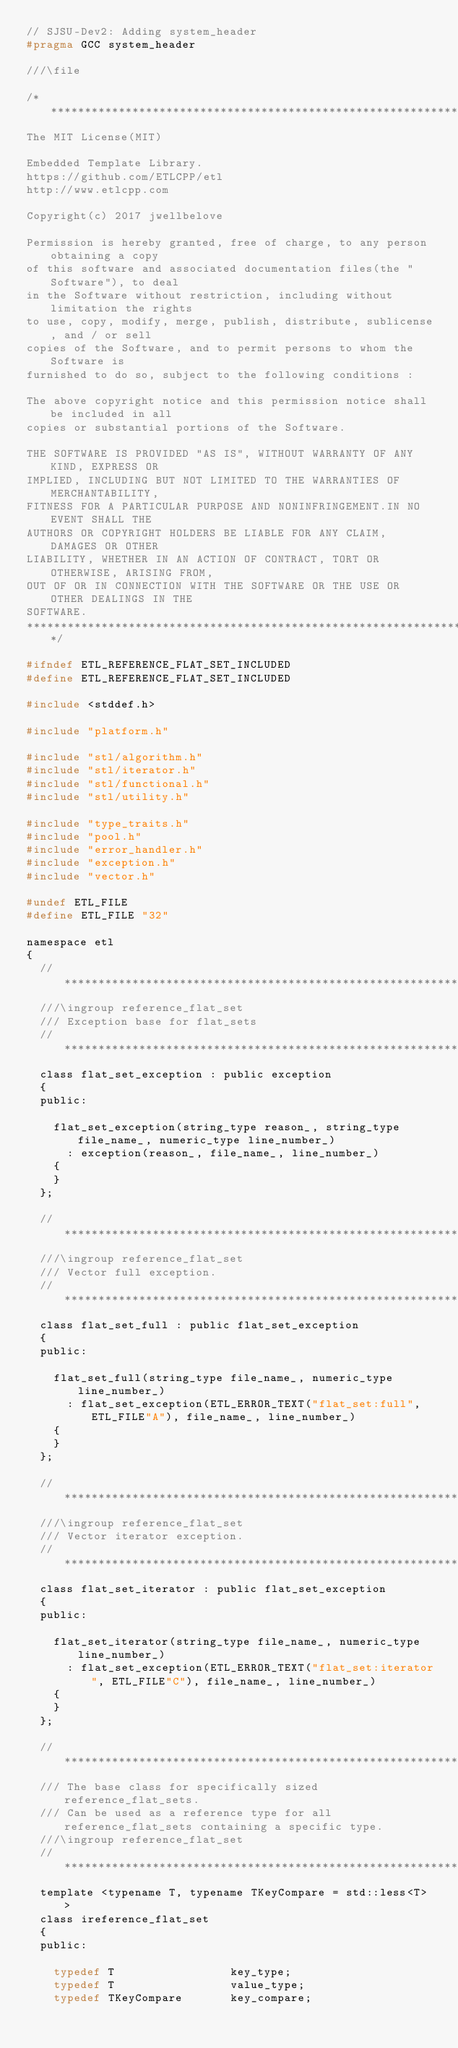<code> <loc_0><loc_0><loc_500><loc_500><_C_>// SJSU-Dev2: Adding system_header
#pragma GCC system_header

///\file

/******************************************************************************
The MIT License(MIT)

Embedded Template Library.
https://github.com/ETLCPP/etl
http://www.etlcpp.com

Copyright(c) 2017 jwellbelove

Permission is hereby granted, free of charge, to any person obtaining a copy
of this software and associated documentation files(the "Software"), to deal
in the Software without restriction, including without limitation the rights
to use, copy, modify, merge, publish, distribute, sublicense, and / or sell
copies of the Software, and to permit persons to whom the Software is
furnished to do so, subject to the following conditions :

The above copyright notice and this permission notice shall be included in all
copies or substantial portions of the Software.

THE SOFTWARE IS PROVIDED "AS IS", WITHOUT WARRANTY OF ANY KIND, EXPRESS OR
IMPLIED, INCLUDING BUT NOT LIMITED TO THE WARRANTIES OF MERCHANTABILITY,
FITNESS FOR A PARTICULAR PURPOSE AND NONINFRINGEMENT.IN NO EVENT SHALL THE
AUTHORS OR COPYRIGHT HOLDERS BE LIABLE FOR ANY CLAIM, DAMAGES OR OTHER
LIABILITY, WHETHER IN AN ACTION OF CONTRACT, TORT OR OTHERWISE, ARISING FROM,
OUT OF OR IN CONNECTION WITH THE SOFTWARE OR THE USE OR OTHER DEALINGS IN THE
SOFTWARE.
******************************************************************************/

#ifndef ETL_REFERENCE_FLAT_SET_INCLUDED
#define ETL_REFERENCE_FLAT_SET_INCLUDED

#include <stddef.h>

#include "platform.h"

#include "stl/algorithm.h"
#include "stl/iterator.h"
#include "stl/functional.h"
#include "stl/utility.h"

#include "type_traits.h"
#include "pool.h"
#include "error_handler.h"
#include "exception.h"
#include "vector.h"

#undef ETL_FILE
#define ETL_FILE "32"

namespace etl
{
  //***************************************************************************
  ///\ingroup reference_flat_set
  /// Exception base for flat_sets
  //***************************************************************************
  class flat_set_exception : public exception
  {
  public:

    flat_set_exception(string_type reason_, string_type file_name_, numeric_type line_number_)
      : exception(reason_, file_name_, line_number_)
    {
    }
  };

  //***************************************************************************
  ///\ingroup reference_flat_set
  /// Vector full exception.
  //***************************************************************************
  class flat_set_full : public flat_set_exception
  {
  public:

    flat_set_full(string_type file_name_, numeric_type line_number_)
      : flat_set_exception(ETL_ERROR_TEXT("flat_set:full", ETL_FILE"A"), file_name_, line_number_)
    {
    }
  };

  //***************************************************************************
  ///\ingroup reference_flat_set
  /// Vector iterator exception.
  //***************************************************************************
  class flat_set_iterator : public flat_set_exception
  {
  public:

    flat_set_iterator(string_type file_name_, numeric_type line_number_)
      : flat_set_exception(ETL_ERROR_TEXT("flat_set:iterator", ETL_FILE"C"), file_name_, line_number_)
    {
    }
  };

  //***************************************************************************
  /// The base class for specifically sized reference_flat_sets.
  /// Can be used as a reference type for all reference_flat_sets containing a specific type.
  ///\ingroup reference_flat_set
  //***************************************************************************
  template <typename T, typename TKeyCompare = std::less<T> >
  class ireference_flat_set
  {
  public:

    typedef T                 key_type;
    typedef T                 value_type;
    typedef TKeyCompare       key_compare;</code> 